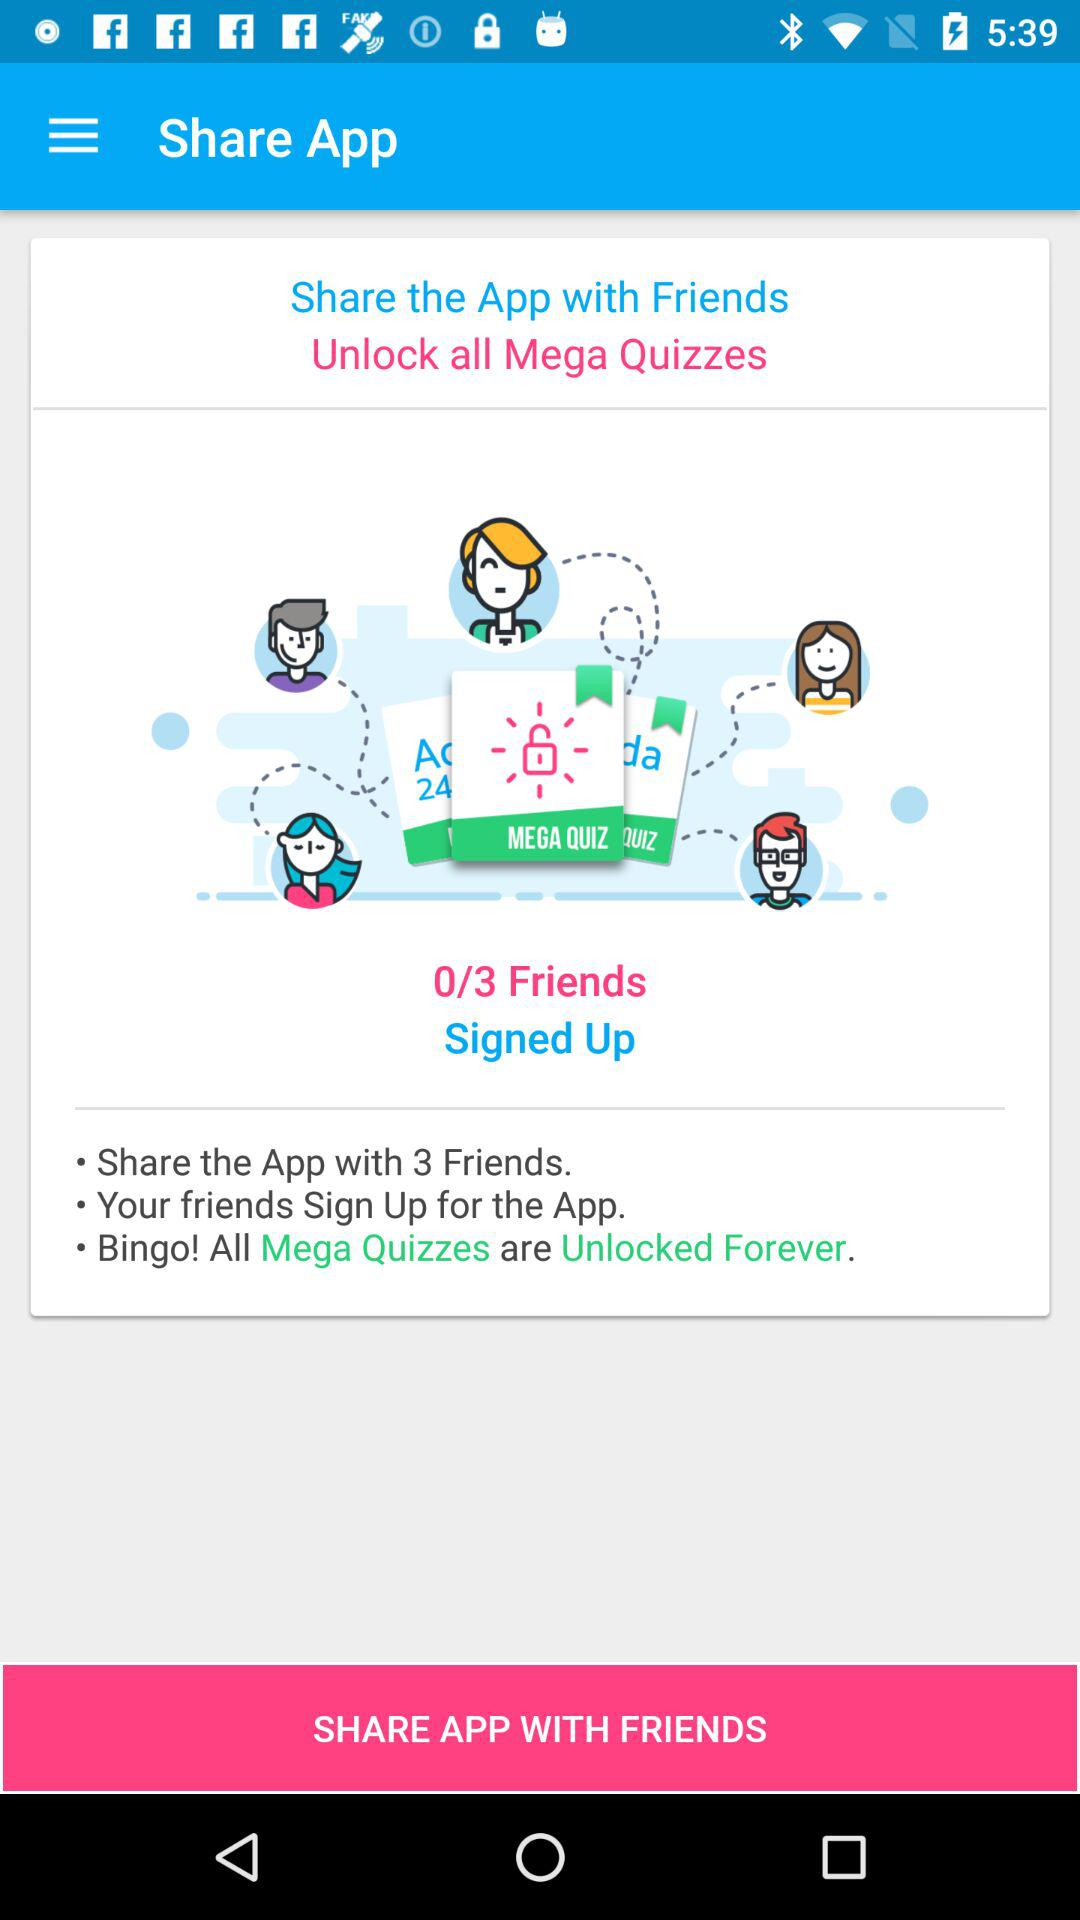With how many friends was this app shared? This app was shared with 0 friends. 